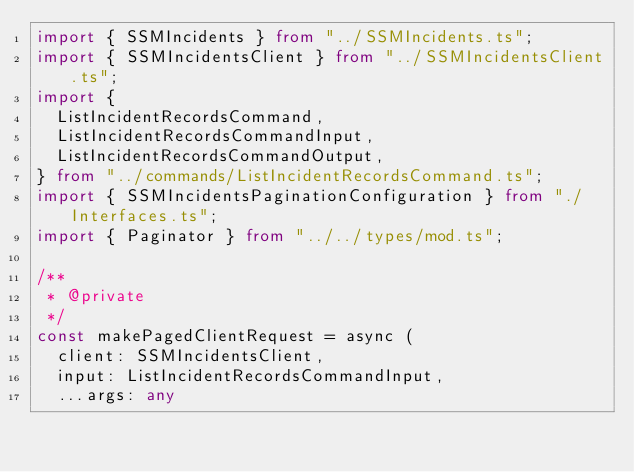Convert code to text. <code><loc_0><loc_0><loc_500><loc_500><_TypeScript_>import { SSMIncidents } from "../SSMIncidents.ts";
import { SSMIncidentsClient } from "../SSMIncidentsClient.ts";
import {
  ListIncidentRecordsCommand,
  ListIncidentRecordsCommandInput,
  ListIncidentRecordsCommandOutput,
} from "../commands/ListIncidentRecordsCommand.ts";
import { SSMIncidentsPaginationConfiguration } from "./Interfaces.ts";
import { Paginator } from "../../types/mod.ts";

/**
 * @private
 */
const makePagedClientRequest = async (
  client: SSMIncidentsClient,
  input: ListIncidentRecordsCommandInput,
  ...args: any</code> 